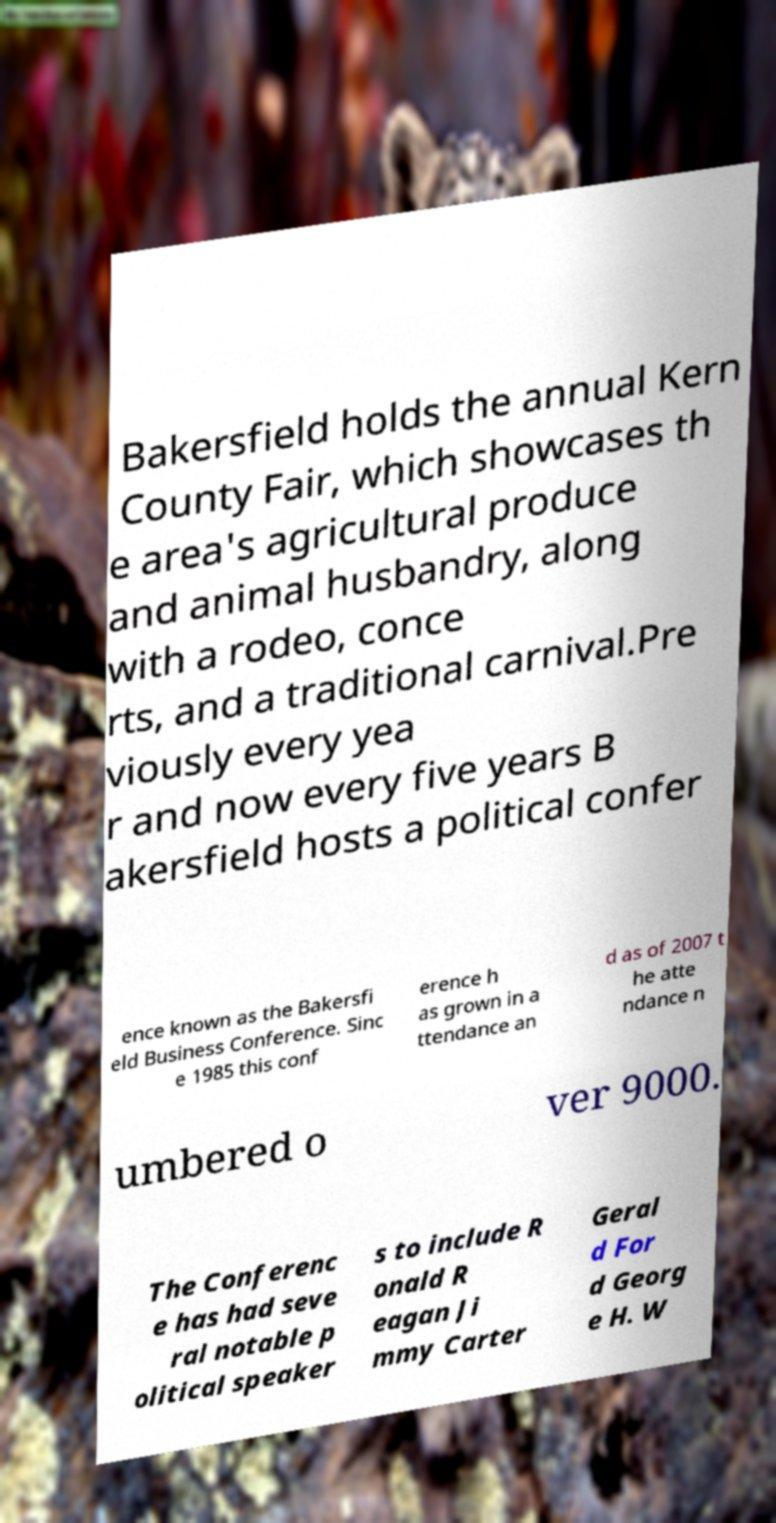Could you assist in decoding the text presented in this image and type it out clearly? Bakersfield holds the annual Kern County Fair, which showcases th e area's agricultural produce and animal husbandry, along with a rodeo, conce rts, and a traditional carnival.Pre viously every yea r and now every five years B akersfield hosts a political confer ence known as the Bakersfi eld Business Conference. Sinc e 1985 this conf erence h as grown in a ttendance an d as of 2007 t he atte ndance n umbered o ver 9000. The Conferenc e has had seve ral notable p olitical speaker s to include R onald R eagan Ji mmy Carter Geral d For d Georg e H. W 